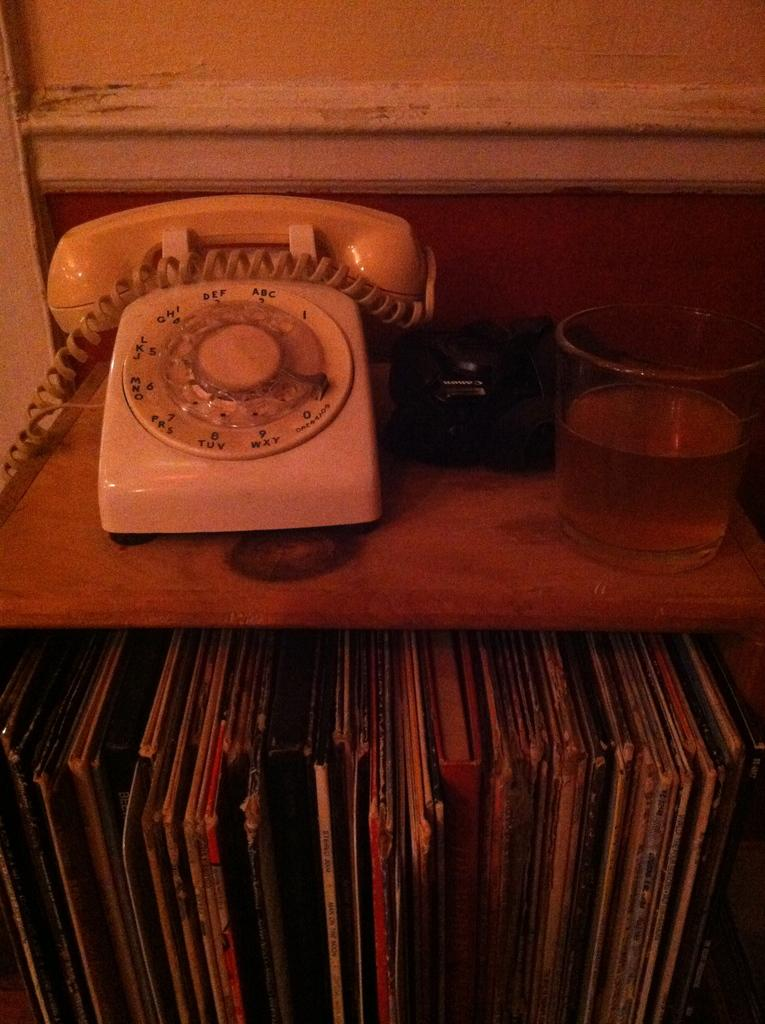Provide a one-sentence caption for the provided image. a phone that has the number 2 on it. 